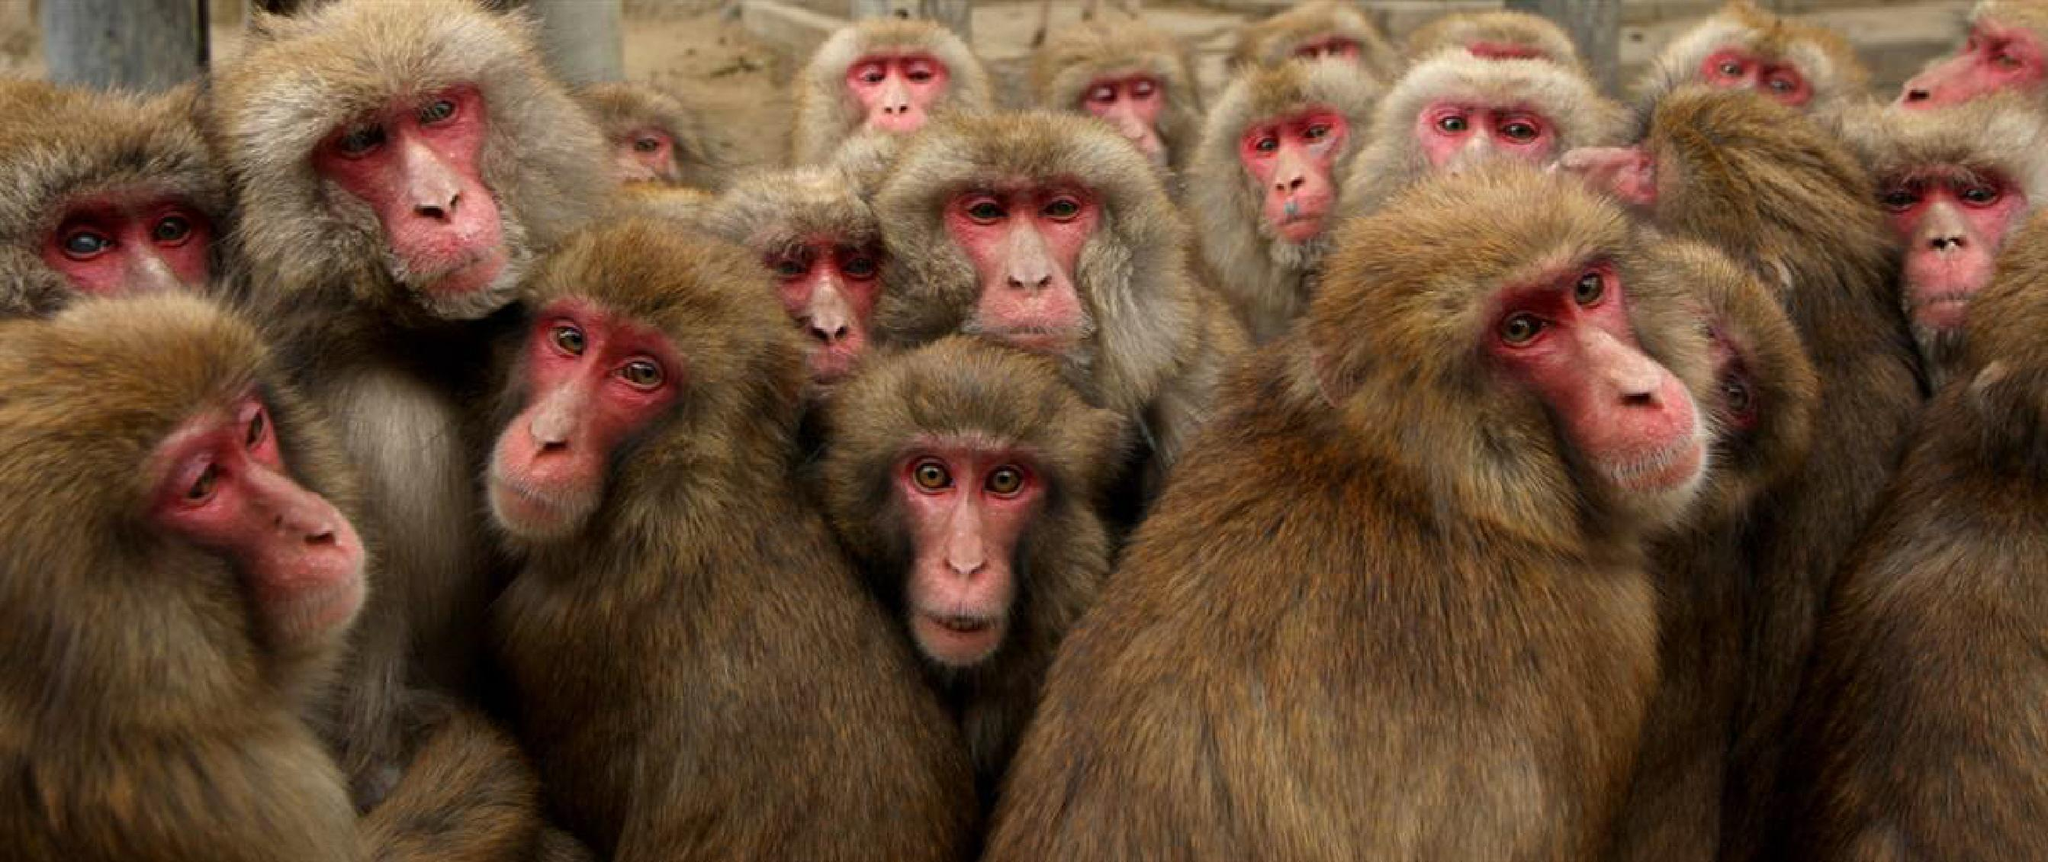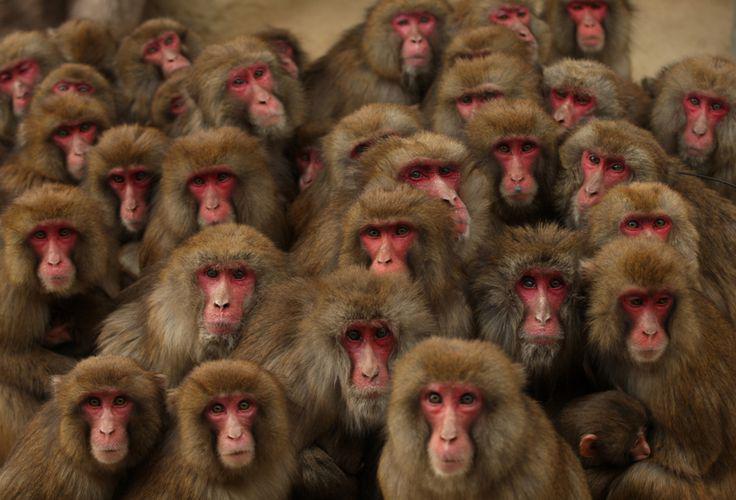The first image is the image on the left, the second image is the image on the right. Given the left and right images, does the statement "There are no more than 6 monkeys in the image on the left." hold true? Answer yes or no. No. 